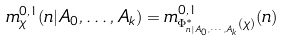<formula> <loc_0><loc_0><loc_500><loc_500>m _ { \chi } ^ { 0 , 1 } ( n | A _ { 0 } , \dots , A _ { k } ) = m ^ { 0 , 1 } _ { \Phi _ { n | A _ { 0 } , \cdots , A _ { k } } ^ { * } ( \chi ) } ( n )</formula> 